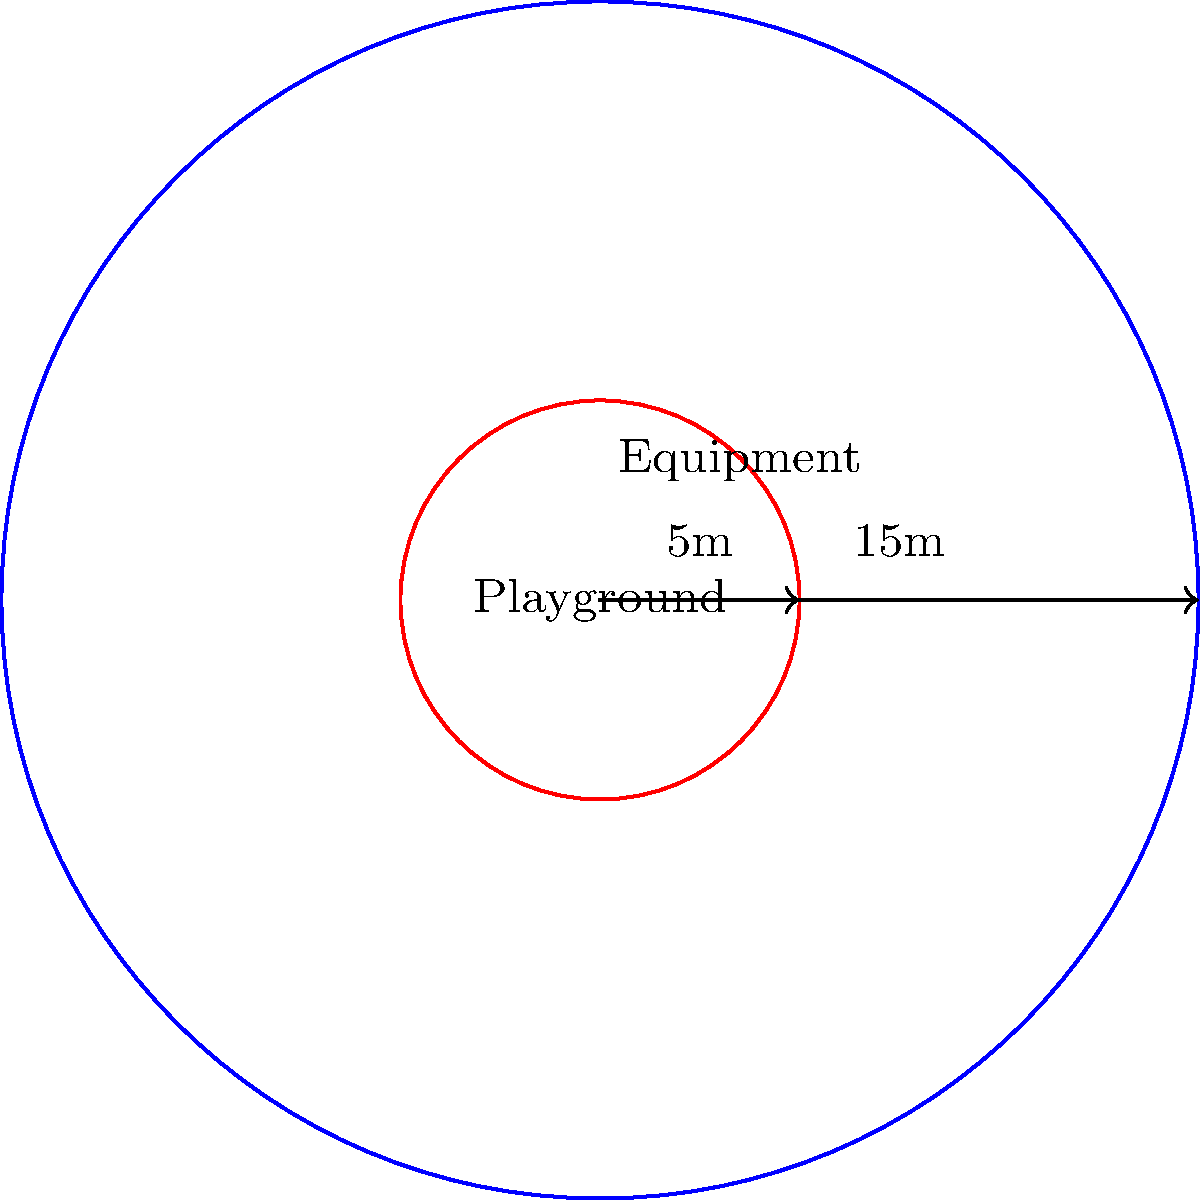A circular playground has a radius of 15 meters. A piece of equipment requires a circular area with a 5-meter radius in the center of the playground. What percentage of the playground's area remains available for children to play after installing the equipment? Let's solve this step-by-step:

1) First, calculate the total area of the playground:
   $$A_{playground} = \pi r^2 = \pi (15)^2 = 225\pi \text{ m}^2$$

2) Next, calculate the area taken up by the equipment:
   $$A_{equipment} = \pi r^2 = \pi (5)^2 = 25\pi \text{ m}^2$$

3) The remaining area for children to play is:
   $$A_{play} = A_{playground} - A_{equipment} = 225\pi - 25\pi = 200\pi \text{ m}^2$$

4) To find the percentage, divide the play area by the total area and multiply by 100:
   $$\text{Percentage} = \frac{A_{play}}{A_{playground}} \times 100 = \frac{200\pi}{225\pi} \times 100 = \frac{200}{225} \times 100 \approx 88.89\%$$

Therefore, approximately 88.89% of the playground's area remains available for children to play.
Answer: 88.89% 